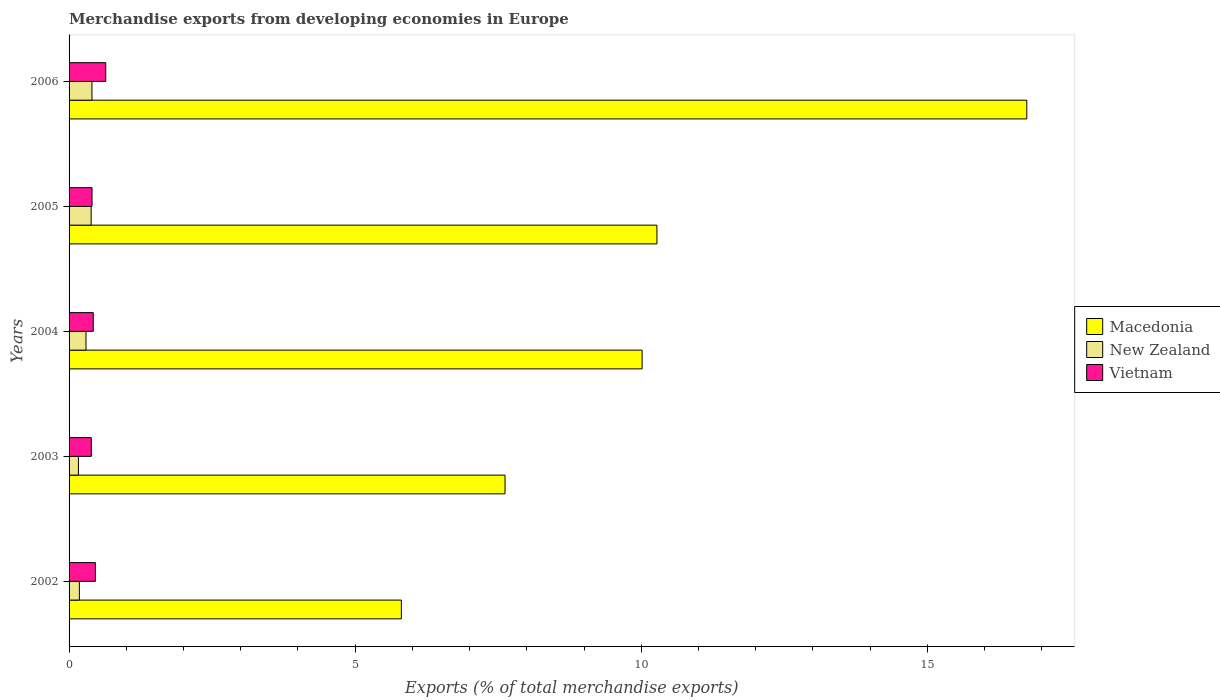Are the number of bars per tick equal to the number of legend labels?
Keep it short and to the point. Yes. How many bars are there on the 5th tick from the top?
Offer a very short reply. 3. How many bars are there on the 4th tick from the bottom?
Your answer should be compact. 3. In how many cases, is the number of bars for a given year not equal to the number of legend labels?
Offer a terse response. 0. What is the percentage of total merchandise exports in Macedonia in 2005?
Your answer should be compact. 10.27. Across all years, what is the maximum percentage of total merchandise exports in New Zealand?
Your answer should be compact. 0.4. Across all years, what is the minimum percentage of total merchandise exports in New Zealand?
Make the answer very short. 0.16. In which year was the percentage of total merchandise exports in New Zealand maximum?
Ensure brevity in your answer.  2006. What is the total percentage of total merchandise exports in New Zealand in the graph?
Keep it short and to the point. 1.43. What is the difference between the percentage of total merchandise exports in Vietnam in 2004 and that in 2006?
Keep it short and to the point. -0.22. What is the difference between the percentage of total merchandise exports in Macedonia in 2006 and the percentage of total merchandise exports in New Zealand in 2003?
Give a very brief answer. 16.57. What is the average percentage of total merchandise exports in Vietnam per year?
Offer a terse response. 0.46. In the year 2005, what is the difference between the percentage of total merchandise exports in New Zealand and percentage of total merchandise exports in Vietnam?
Your answer should be very brief. -0.02. In how many years, is the percentage of total merchandise exports in Vietnam greater than 13 %?
Make the answer very short. 0. What is the ratio of the percentage of total merchandise exports in Macedonia in 2003 to that in 2004?
Offer a very short reply. 0.76. Is the percentage of total merchandise exports in Macedonia in 2004 less than that in 2005?
Keep it short and to the point. Yes. What is the difference between the highest and the second highest percentage of total merchandise exports in New Zealand?
Keep it short and to the point. 0.01. What is the difference between the highest and the lowest percentage of total merchandise exports in Macedonia?
Keep it short and to the point. 10.93. Is the sum of the percentage of total merchandise exports in Macedonia in 2002 and 2003 greater than the maximum percentage of total merchandise exports in New Zealand across all years?
Provide a short and direct response. Yes. What does the 1st bar from the top in 2003 represents?
Keep it short and to the point. Vietnam. What does the 3rd bar from the bottom in 2002 represents?
Your answer should be very brief. Vietnam. Is it the case that in every year, the sum of the percentage of total merchandise exports in Macedonia and percentage of total merchandise exports in Vietnam is greater than the percentage of total merchandise exports in New Zealand?
Your answer should be very brief. Yes. How many years are there in the graph?
Ensure brevity in your answer.  5. Does the graph contain grids?
Give a very brief answer. No. Where does the legend appear in the graph?
Offer a terse response. Center right. How are the legend labels stacked?
Make the answer very short. Vertical. What is the title of the graph?
Your answer should be compact. Merchandise exports from developing economies in Europe. Does "Maldives" appear as one of the legend labels in the graph?
Offer a very short reply. No. What is the label or title of the X-axis?
Keep it short and to the point. Exports (% of total merchandise exports). What is the label or title of the Y-axis?
Your answer should be compact. Years. What is the Exports (% of total merchandise exports) of Macedonia in 2002?
Offer a terse response. 5.81. What is the Exports (% of total merchandise exports) of New Zealand in 2002?
Ensure brevity in your answer.  0.18. What is the Exports (% of total merchandise exports) of Vietnam in 2002?
Provide a short and direct response. 0.46. What is the Exports (% of total merchandise exports) in Macedonia in 2003?
Ensure brevity in your answer.  7.62. What is the Exports (% of total merchandise exports) of New Zealand in 2003?
Offer a very short reply. 0.16. What is the Exports (% of total merchandise exports) in Vietnam in 2003?
Offer a terse response. 0.39. What is the Exports (% of total merchandise exports) of Macedonia in 2004?
Your answer should be compact. 10.01. What is the Exports (% of total merchandise exports) of New Zealand in 2004?
Provide a short and direct response. 0.3. What is the Exports (% of total merchandise exports) of Vietnam in 2004?
Keep it short and to the point. 0.42. What is the Exports (% of total merchandise exports) in Macedonia in 2005?
Make the answer very short. 10.27. What is the Exports (% of total merchandise exports) of New Zealand in 2005?
Your answer should be compact. 0.39. What is the Exports (% of total merchandise exports) in Vietnam in 2005?
Your answer should be compact. 0.4. What is the Exports (% of total merchandise exports) in Macedonia in 2006?
Offer a very short reply. 16.74. What is the Exports (% of total merchandise exports) in New Zealand in 2006?
Give a very brief answer. 0.4. What is the Exports (% of total merchandise exports) of Vietnam in 2006?
Give a very brief answer. 0.64. Across all years, what is the maximum Exports (% of total merchandise exports) of Macedonia?
Offer a terse response. 16.74. Across all years, what is the maximum Exports (% of total merchandise exports) in New Zealand?
Give a very brief answer. 0.4. Across all years, what is the maximum Exports (% of total merchandise exports) in Vietnam?
Ensure brevity in your answer.  0.64. Across all years, what is the minimum Exports (% of total merchandise exports) in Macedonia?
Provide a short and direct response. 5.81. Across all years, what is the minimum Exports (% of total merchandise exports) in New Zealand?
Your response must be concise. 0.16. Across all years, what is the minimum Exports (% of total merchandise exports) in Vietnam?
Your response must be concise. 0.39. What is the total Exports (% of total merchandise exports) in Macedonia in the graph?
Ensure brevity in your answer.  50.45. What is the total Exports (% of total merchandise exports) of New Zealand in the graph?
Keep it short and to the point. 1.43. What is the total Exports (% of total merchandise exports) in Vietnam in the graph?
Offer a terse response. 2.31. What is the difference between the Exports (% of total merchandise exports) in Macedonia in 2002 and that in 2003?
Your answer should be compact. -1.81. What is the difference between the Exports (% of total merchandise exports) of New Zealand in 2002 and that in 2003?
Give a very brief answer. 0.02. What is the difference between the Exports (% of total merchandise exports) of Vietnam in 2002 and that in 2003?
Provide a short and direct response. 0.07. What is the difference between the Exports (% of total merchandise exports) of Macedonia in 2002 and that in 2004?
Ensure brevity in your answer.  -4.21. What is the difference between the Exports (% of total merchandise exports) of New Zealand in 2002 and that in 2004?
Make the answer very short. -0.12. What is the difference between the Exports (% of total merchandise exports) in Vietnam in 2002 and that in 2004?
Keep it short and to the point. 0.04. What is the difference between the Exports (% of total merchandise exports) of Macedonia in 2002 and that in 2005?
Your answer should be very brief. -4.47. What is the difference between the Exports (% of total merchandise exports) of New Zealand in 2002 and that in 2005?
Make the answer very short. -0.21. What is the difference between the Exports (% of total merchandise exports) of Vietnam in 2002 and that in 2005?
Your response must be concise. 0.06. What is the difference between the Exports (% of total merchandise exports) of Macedonia in 2002 and that in 2006?
Offer a very short reply. -10.93. What is the difference between the Exports (% of total merchandise exports) in New Zealand in 2002 and that in 2006?
Keep it short and to the point. -0.22. What is the difference between the Exports (% of total merchandise exports) of Vietnam in 2002 and that in 2006?
Provide a short and direct response. -0.18. What is the difference between the Exports (% of total merchandise exports) in Macedonia in 2003 and that in 2004?
Your answer should be very brief. -2.4. What is the difference between the Exports (% of total merchandise exports) in New Zealand in 2003 and that in 2004?
Make the answer very short. -0.13. What is the difference between the Exports (% of total merchandise exports) in Vietnam in 2003 and that in 2004?
Provide a short and direct response. -0.03. What is the difference between the Exports (% of total merchandise exports) in Macedonia in 2003 and that in 2005?
Your answer should be compact. -2.65. What is the difference between the Exports (% of total merchandise exports) in New Zealand in 2003 and that in 2005?
Give a very brief answer. -0.22. What is the difference between the Exports (% of total merchandise exports) of Vietnam in 2003 and that in 2005?
Provide a short and direct response. -0.01. What is the difference between the Exports (% of total merchandise exports) of Macedonia in 2003 and that in 2006?
Ensure brevity in your answer.  -9.12. What is the difference between the Exports (% of total merchandise exports) in New Zealand in 2003 and that in 2006?
Keep it short and to the point. -0.24. What is the difference between the Exports (% of total merchandise exports) of Vietnam in 2003 and that in 2006?
Your answer should be very brief. -0.25. What is the difference between the Exports (% of total merchandise exports) of Macedonia in 2004 and that in 2005?
Ensure brevity in your answer.  -0.26. What is the difference between the Exports (% of total merchandise exports) in New Zealand in 2004 and that in 2005?
Your response must be concise. -0.09. What is the difference between the Exports (% of total merchandise exports) of Vietnam in 2004 and that in 2005?
Ensure brevity in your answer.  0.02. What is the difference between the Exports (% of total merchandise exports) in Macedonia in 2004 and that in 2006?
Your response must be concise. -6.72. What is the difference between the Exports (% of total merchandise exports) of New Zealand in 2004 and that in 2006?
Make the answer very short. -0.1. What is the difference between the Exports (% of total merchandise exports) of Vietnam in 2004 and that in 2006?
Offer a terse response. -0.22. What is the difference between the Exports (% of total merchandise exports) in Macedonia in 2005 and that in 2006?
Give a very brief answer. -6.46. What is the difference between the Exports (% of total merchandise exports) in New Zealand in 2005 and that in 2006?
Ensure brevity in your answer.  -0.01. What is the difference between the Exports (% of total merchandise exports) of Vietnam in 2005 and that in 2006?
Give a very brief answer. -0.24. What is the difference between the Exports (% of total merchandise exports) in Macedonia in 2002 and the Exports (% of total merchandise exports) in New Zealand in 2003?
Ensure brevity in your answer.  5.64. What is the difference between the Exports (% of total merchandise exports) in Macedonia in 2002 and the Exports (% of total merchandise exports) in Vietnam in 2003?
Provide a short and direct response. 5.42. What is the difference between the Exports (% of total merchandise exports) of New Zealand in 2002 and the Exports (% of total merchandise exports) of Vietnam in 2003?
Provide a short and direct response. -0.21. What is the difference between the Exports (% of total merchandise exports) in Macedonia in 2002 and the Exports (% of total merchandise exports) in New Zealand in 2004?
Provide a succinct answer. 5.51. What is the difference between the Exports (% of total merchandise exports) in Macedonia in 2002 and the Exports (% of total merchandise exports) in Vietnam in 2004?
Offer a terse response. 5.38. What is the difference between the Exports (% of total merchandise exports) in New Zealand in 2002 and the Exports (% of total merchandise exports) in Vietnam in 2004?
Your answer should be compact. -0.24. What is the difference between the Exports (% of total merchandise exports) in Macedonia in 2002 and the Exports (% of total merchandise exports) in New Zealand in 2005?
Your response must be concise. 5.42. What is the difference between the Exports (% of total merchandise exports) in Macedonia in 2002 and the Exports (% of total merchandise exports) in Vietnam in 2005?
Your response must be concise. 5.41. What is the difference between the Exports (% of total merchandise exports) of New Zealand in 2002 and the Exports (% of total merchandise exports) of Vietnam in 2005?
Ensure brevity in your answer.  -0.22. What is the difference between the Exports (% of total merchandise exports) of Macedonia in 2002 and the Exports (% of total merchandise exports) of New Zealand in 2006?
Provide a short and direct response. 5.41. What is the difference between the Exports (% of total merchandise exports) of Macedonia in 2002 and the Exports (% of total merchandise exports) of Vietnam in 2006?
Your response must be concise. 5.17. What is the difference between the Exports (% of total merchandise exports) of New Zealand in 2002 and the Exports (% of total merchandise exports) of Vietnam in 2006?
Keep it short and to the point. -0.46. What is the difference between the Exports (% of total merchandise exports) of Macedonia in 2003 and the Exports (% of total merchandise exports) of New Zealand in 2004?
Your answer should be compact. 7.32. What is the difference between the Exports (% of total merchandise exports) in Macedonia in 2003 and the Exports (% of total merchandise exports) in Vietnam in 2004?
Make the answer very short. 7.2. What is the difference between the Exports (% of total merchandise exports) in New Zealand in 2003 and the Exports (% of total merchandise exports) in Vietnam in 2004?
Give a very brief answer. -0.26. What is the difference between the Exports (% of total merchandise exports) of Macedonia in 2003 and the Exports (% of total merchandise exports) of New Zealand in 2005?
Provide a short and direct response. 7.23. What is the difference between the Exports (% of total merchandise exports) of Macedonia in 2003 and the Exports (% of total merchandise exports) of Vietnam in 2005?
Keep it short and to the point. 7.22. What is the difference between the Exports (% of total merchandise exports) in New Zealand in 2003 and the Exports (% of total merchandise exports) in Vietnam in 2005?
Offer a very short reply. -0.24. What is the difference between the Exports (% of total merchandise exports) of Macedonia in 2003 and the Exports (% of total merchandise exports) of New Zealand in 2006?
Your answer should be compact. 7.22. What is the difference between the Exports (% of total merchandise exports) of Macedonia in 2003 and the Exports (% of total merchandise exports) of Vietnam in 2006?
Your response must be concise. 6.98. What is the difference between the Exports (% of total merchandise exports) of New Zealand in 2003 and the Exports (% of total merchandise exports) of Vietnam in 2006?
Your response must be concise. -0.48. What is the difference between the Exports (% of total merchandise exports) in Macedonia in 2004 and the Exports (% of total merchandise exports) in New Zealand in 2005?
Offer a terse response. 9.63. What is the difference between the Exports (% of total merchandise exports) of Macedonia in 2004 and the Exports (% of total merchandise exports) of Vietnam in 2005?
Provide a succinct answer. 9.61. What is the difference between the Exports (% of total merchandise exports) in New Zealand in 2004 and the Exports (% of total merchandise exports) in Vietnam in 2005?
Ensure brevity in your answer.  -0.1. What is the difference between the Exports (% of total merchandise exports) of Macedonia in 2004 and the Exports (% of total merchandise exports) of New Zealand in 2006?
Offer a terse response. 9.61. What is the difference between the Exports (% of total merchandise exports) in Macedonia in 2004 and the Exports (% of total merchandise exports) in Vietnam in 2006?
Provide a short and direct response. 9.37. What is the difference between the Exports (% of total merchandise exports) in New Zealand in 2004 and the Exports (% of total merchandise exports) in Vietnam in 2006?
Your response must be concise. -0.34. What is the difference between the Exports (% of total merchandise exports) in Macedonia in 2005 and the Exports (% of total merchandise exports) in New Zealand in 2006?
Make the answer very short. 9.87. What is the difference between the Exports (% of total merchandise exports) in Macedonia in 2005 and the Exports (% of total merchandise exports) in Vietnam in 2006?
Offer a very short reply. 9.63. What is the difference between the Exports (% of total merchandise exports) in New Zealand in 2005 and the Exports (% of total merchandise exports) in Vietnam in 2006?
Ensure brevity in your answer.  -0.26. What is the average Exports (% of total merchandise exports) of Macedonia per year?
Your answer should be very brief. 10.09. What is the average Exports (% of total merchandise exports) in New Zealand per year?
Keep it short and to the point. 0.28. What is the average Exports (% of total merchandise exports) in Vietnam per year?
Ensure brevity in your answer.  0.46. In the year 2002, what is the difference between the Exports (% of total merchandise exports) in Macedonia and Exports (% of total merchandise exports) in New Zealand?
Provide a succinct answer. 5.63. In the year 2002, what is the difference between the Exports (% of total merchandise exports) in Macedonia and Exports (% of total merchandise exports) in Vietnam?
Give a very brief answer. 5.35. In the year 2002, what is the difference between the Exports (% of total merchandise exports) in New Zealand and Exports (% of total merchandise exports) in Vietnam?
Your answer should be very brief. -0.28. In the year 2003, what is the difference between the Exports (% of total merchandise exports) of Macedonia and Exports (% of total merchandise exports) of New Zealand?
Your answer should be very brief. 7.46. In the year 2003, what is the difference between the Exports (% of total merchandise exports) in Macedonia and Exports (% of total merchandise exports) in Vietnam?
Ensure brevity in your answer.  7.23. In the year 2003, what is the difference between the Exports (% of total merchandise exports) in New Zealand and Exports (% of total merchandise exports) in Vietnam?
Offer a terse response. -0.23. In the year 2004, what is the difference between the Exports (% of total merchandise exports) in Macedonia and Exports (% of total merchandise exports) in New Zealand?
Ensure brevity in your answer.  9.72. In the year 2004, what is the difference between the Exports (% of total merchandise exports) of Macedonia and Exports (% of total merchandise exports) of Vietnam?
Make the answer very short. 9.59. In the year 2004, what is the difference between the Exports (% of total merchandise exports) in New Zealand and Exports (% of total merchandise exports) in Vietnam?
Provide a succinct answer. -0.13. In the year 2005, what is the difference between the Exports (% of total merchandise exports) in Macedonia and Exports (% of total merchandise exports) in New Zealand?
Keep it short and to the point. 9.89. In the year 2005, what is the difference between the Exports (% of total merchandise exports) in Macedonia and Exports (% of total merchandise exports) in Vietnam?
Your response must be concise. 9.87. In the year 2005, what is the difference between the Exports (% of total merchandise exports) in New Zealand and Exports (% of total merchandise exports) in Vietnam?
Provide a short and direct response. -0.02. In the year 2006, what is the difference between the Exports (% of total merchandise exports) in Macedonia and Exports (% of total merchandise exports) in New Zealand?
Offer a terse response. 16.34. In the year 2006, what is the difference between the Exports (% of total merchandise exports) in Macedonia and Exports (% of total merchandise exports) in Vietnam?
Keep it short and to the point. 16.1. In the year 2006, what is the difference between the Exports (% of total merchandise exports) in New Zealand and Exports (% of total merchandise exports) in Vietnam?
Give a very brief answer. -0.24. What is the ratio of the Exports (% of total merchandise exports) in Macedonia in 2002 to that in 2003?
Your answer should be very brief. 0.76. What is the ratio of the Exports (% of total merchandise exports) of New Zealand in 2002 to that in 2003?
Your answer should be very brief. 1.1. What is the ratio of the Exports (% of total merchandise exports) in Vietnam in 2002 to that in 2003?
Give a very brief answer. 1.18. What is the ratio of the Exports (% of total merchandise exports) of Macedonia in 2002 to that in 2004?
Make the answer very short. 0.58. What is the ratio of the Exports (% of total merchandise exports) of New Zealand in 2002 to that in 2004?
Your response must be concise. 0.61. What is the ratio of the Exports (% of total merchandise exports) in Vietnam in 2002 to that in 2004?
Keep it short and to the point. 1.09. What is the ratio of the Exports (% of total merchandise exports) of Macedonia in 2002 to that in 2005?
Offer a very short reply. 0.57. What is the ratio of the Exports (% of total merchandise exports) of New Zealand in 2002 to that in 2005?
Keep it short and to the point. 0.47. What is the ratio of the Exports (% of total merchandise exports) in Vietnam in 2002 to that in 2005?
Your answer should be very brief. 1.15. What is the ratio of the Exports (% of total merchandise exports) of Macedonia in 2002 to that in 2006?
Provide a succinct answer. 0.35. What is the ratio of the Exports (% of total merchandise exports) of New Zealand in 2002 to that in 2006?
Your answer should be very brief. 0.45. What is the ratio of the Exports (% of total merchandise exports) in Vietnam in 2002 to that in 2006?
Your response must be concise. 0.72. What is the ratio of the Exports (% of total merchandise exports) of Macedonia in 2003 to that in 2004?
Offer a terse response. 0.76. What is the ratio of the Exports (% of total merchandise exports) of New Zealand in 2003 to that in 2004?
Provide a short and direct response. 0.55. What is the ratio of the Exports (% of total merchandise exports) in Vietnam in 2003 to that in 2004?
Keep it short and to the point. 0.92. What is the ratio of the Exports (% of total merchandise exports) in Macedonia in 2003 to that in 2005?
Ensure brevity in your answer.  0.74. What is the ratio of the Exports (% of total merchandise exports) in New Zealand in 2003 to that in 2005?
Your response must be concise. 0.42. What is the ratio of the Exports (% of total merchandise exports) in Vietnam in 2003 to that in 2005?
Your answer should be very brief. 0.97. What is the ratio of the Exports (% of total merchandise exports) of Macedonia in 2003 to that in 2006?
Provide a short and direct response. 0.46. What is the ratio of the Exports (% of total merchandise exports) of New Zealand in 2003 to that in 2006?
Your response must be concise. 0.41. What is the ratio of the Exports (% of total merchandise exports) of Vietnam in 2003 to that in 2006?
Your answer should be compact. 0.61. What is the ratio of the Exports (% of total merchandise exports) in Macedonia in 2004 to that in 2005?
Provide a short and direct response. 0.97. What is the ratio of the Exports (% of total merchandise exports) in New Zealand in 2004 to that in 2005?
Provide a succinct answer. 0.77. What is the ratio of the Exports (% of total merchandise exports) of Vietnam in 2004 to that in 2005?
Ensure brevity in your answer.  1.05. What is the ratio of the Exports (% of total merchandise exports) in Macedonia in 2004 to that in 2006?
Your answer should be very brief. 0.6. What is the ratio of the Exports (% of total merchandise exports) in New Zealand in 2004 to that in 2006?
Your answer should be compact. 0.74. What is the ratio of the Exports (% of total merchandise exports) of Vietnam in 2004 to that in 2006?
Keep it short and to the point. 0.66. What is the ratio of the Exports (% of total merchandise exports) of Macedonia in 2005 to that in 2006?
Make the answer very short. 0.61. What is the ratio of the Exports (% of total merchandise exports) in New Zealand in 2005 to that in 2006?
Your answer should be very brief. 0.96. What is the ratio of the Exports (% of total merchandise exports) of Vietnam in 2005 to that in 2006?
Your answer should be compact. 0.63. What is the difference between the highest and the second highest Exports (% of total merchandise exports) in Macedonia?
Offer a terse response. 6.46. What is the difference between the highest and the second highest Exports (% of total merchandise exports) of New Zealand?
Ensure brevity in your answer.  0.01. What is the difference between the highest and the second highest Exports (% of total merchandise exports) in Vietnam?
Your answer should be very brief. 0.18. What is the difference between the highest and the lowest Exports (% of total merchandise exports) in Macedonia?
Ensure brevity in your answer.  10.93. What is the difference between the highest and the lowest Exports (% of total merchandise exports) in New Zealand?
Provide a succinct answer. 0.24. What is the difference between the highest and the lowest Exports (% of total merchandise exports) of Vietnam?
Keep it short and to the point. 0.25. 